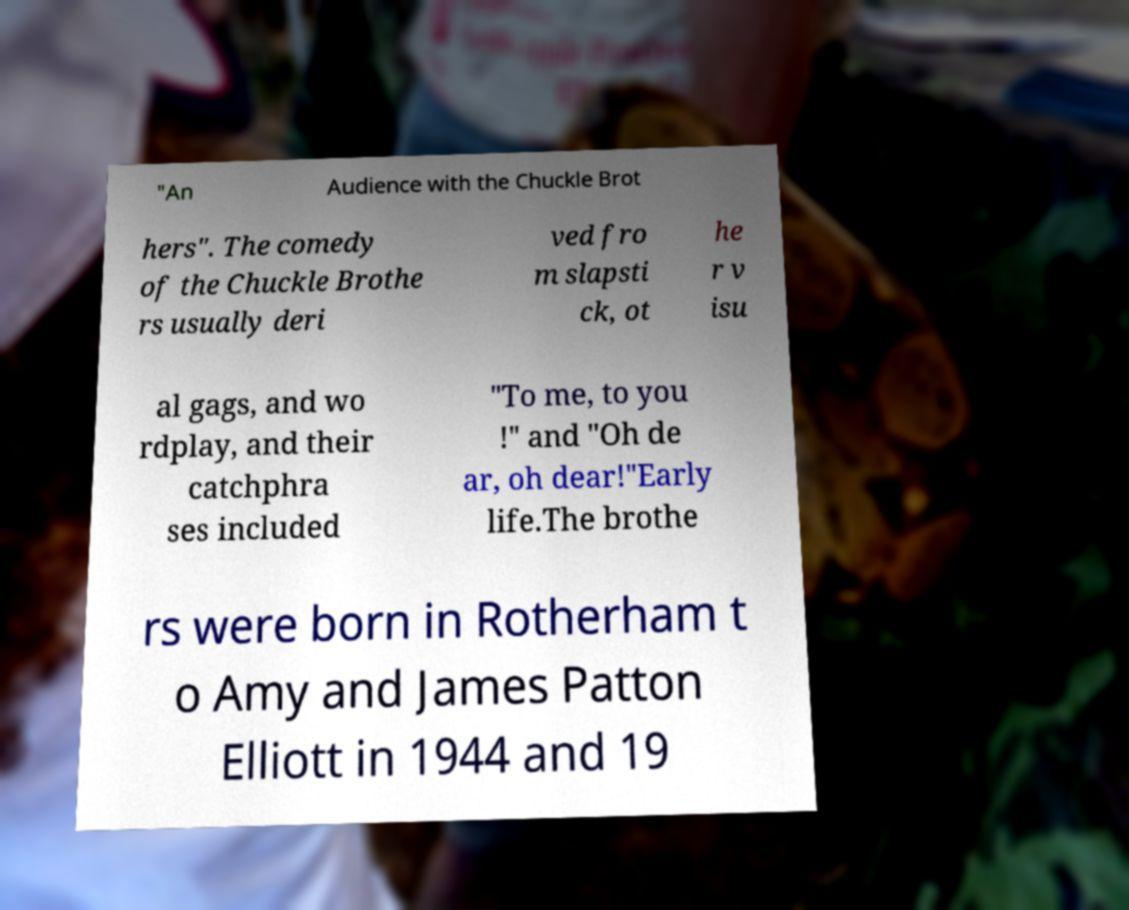For documentation purposes, I need the text within this image transcribed. Could you provide that? "An Audience with the Chuckle Brot hers". The comedy of the Chuckle Brothe rs usually deri ved fro m slapsti ck, ot he r v isu al gags, and wo rdplay, and their catchphra ses included "To me, to you !" and "Oh de ar, oh dear!"Early life.The brothe rs were born in Rotherham t o Amy and James Patton Elliott in 1944 and 19 